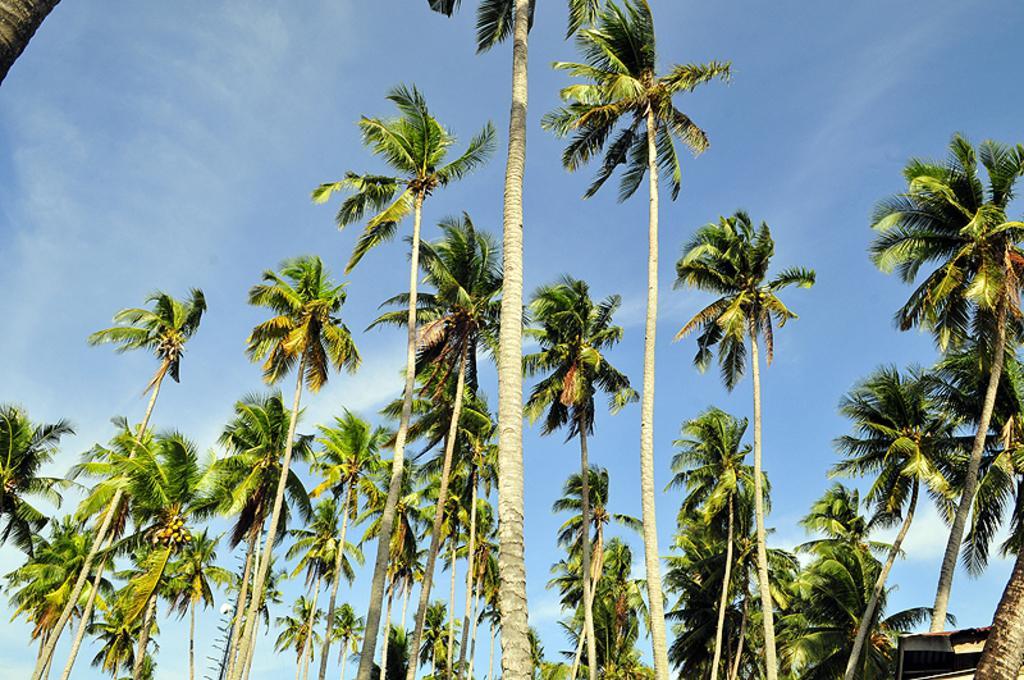Could you give a brief overview of what you see in this image? In this picture we can observe number of coconut trees. In the background there is a sky with some clouds. 